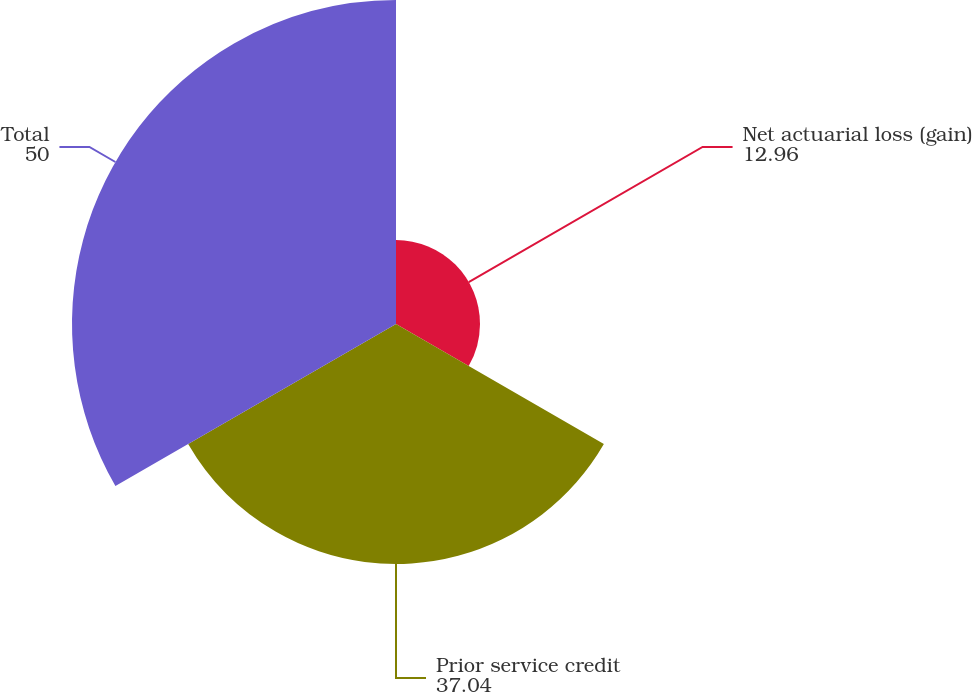Convert chart. <chart><loc_0><loc_0><loc_500><loc_500><pie_chart><fcel>Net actuarial loss (gain)<fcel>Prior service credit<fcel>Total<nl><fcel>12.96%<fcel>37.04%<fcel>50.0%<nl></chart> 